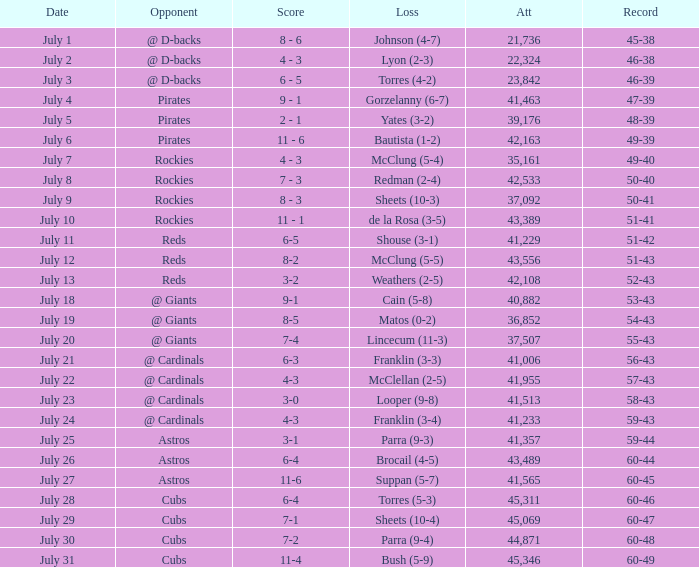What's the attendance of the game where there was a Loss of Yates (3-2)? 39176.0. 